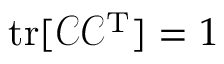<formula> <loc_0><loc_0><loc_500><loc_500>t r [ \mathcal { C } \mathcal { C } ^ { T } ] = 1</formula> 